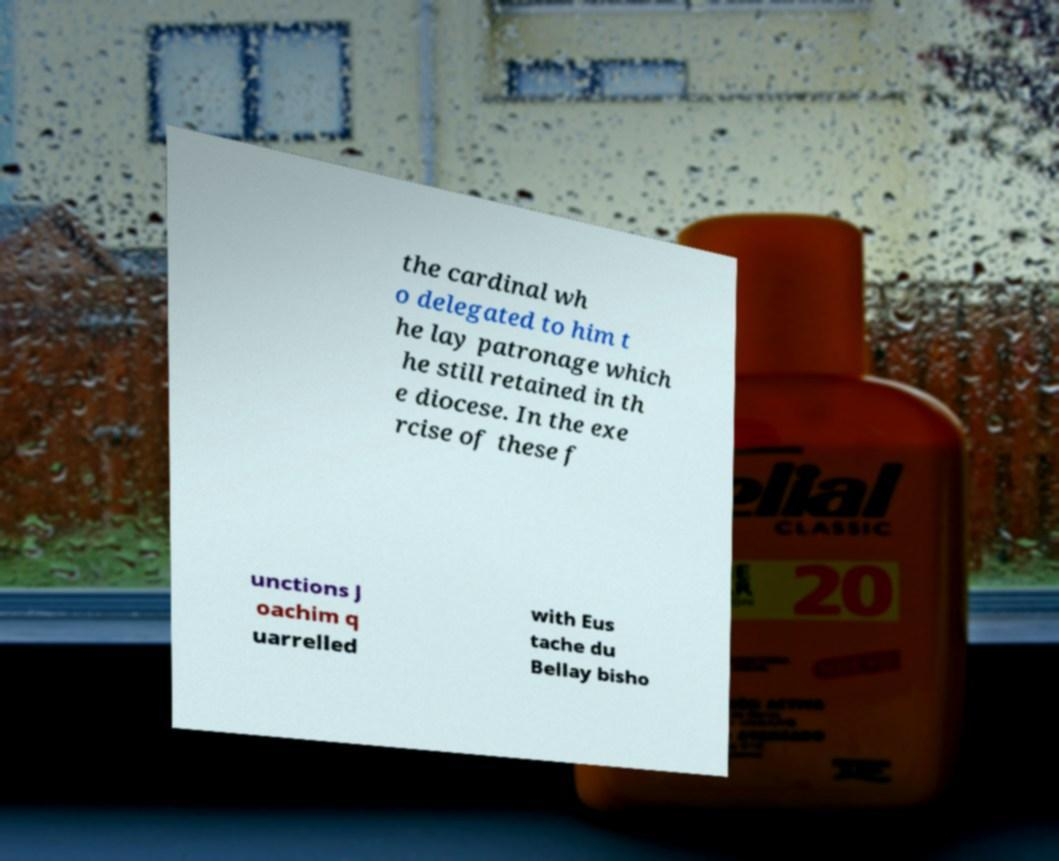There's text embedded in this image that I need extracted. Can you transcribe it verbatim? the cardinal wh o delegated to him t he lay patronage which he still retained in th e diocese. In the exe rcise of these f unctions J oachim q uarrelled with Eus tache du Bellay bisho 